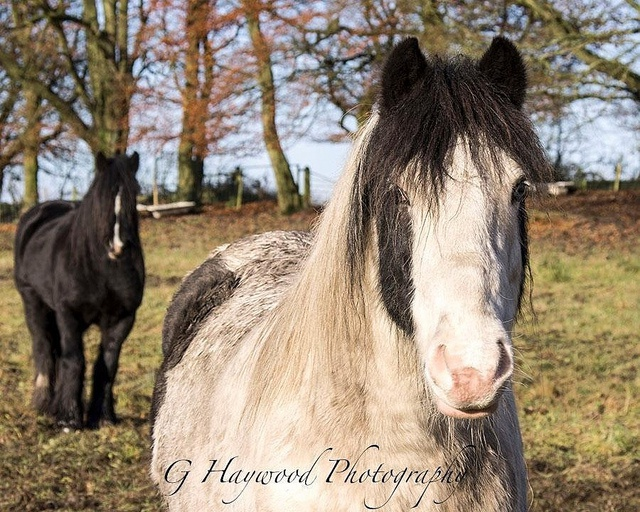Describe the objects in this image and their specific colors. I can see horse in gray, ivory, tan, and black tones and horse in gray and black tones in this image. 